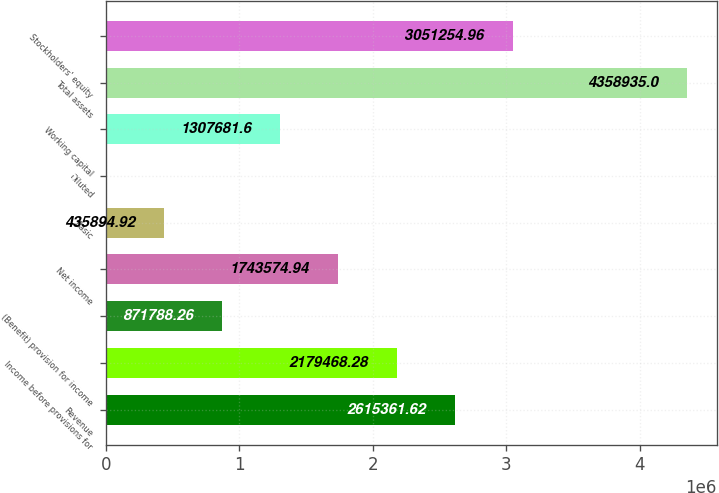Convert chart to OTSL. <chart><loc_0><loc_0><loc_500><loc_500><bar_chart><fcel>Revenue<fcel>Income before provisions for<fcel>(Benefit) provision for income<fcel>Net income<fcel>Basic<fcel>Diluted<fcel>Working capital<fcel>Total assets<fcel>Stockholders' equity<nl><fcel>2.61536e+06<fcel>2.17947e+06<fcel>871788<fcel>1.74357e+06<fcel>435895<fcel>1.58<fcel>1.30768e+06<fcel>4.35894e+06<fcel>3.05125e+06<nl></chart> 